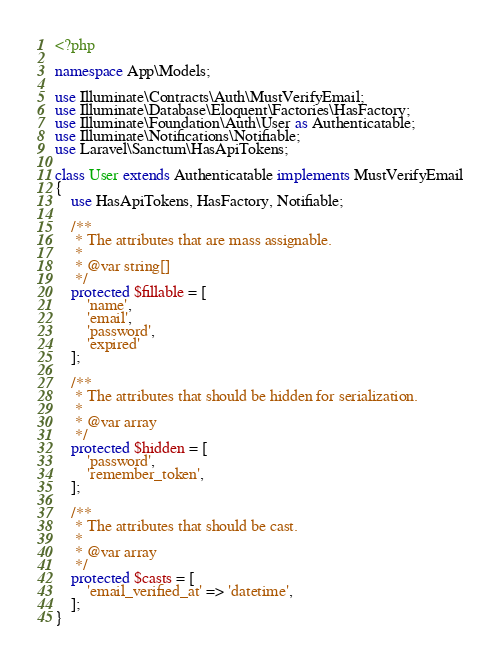<code> <loc_0><loc_0><loc_500><loc_500><_PHP_><?php

namespace App\Models;

use Illuminate\Contracts\Auth\MustVerifyEmail;
use Illuminate\Database\Eloquent\Factories\HasFactory;
use Illuminate\Foundation\Auth\User as Authenticatable;
use Illuminate\Notifications\Notifiable;
use Laravel\Sanctum\HasApiTokens;

class User extends Authenticatable implements MustVerifyEmail
{
    use HasApiTokens, HasFactory, Notifiable;

    /**
     * The attributes that are mass assignable.
     *
     * @var string[]
     */
    protected $fillable = [
        'name',
        'email',
        'password',
        'expired'
    ];

    /**
     * The attributes that should be hidden for serialization.
     *
     * @var array
     */
    protected $hidden = [
        'password',
        'remember_token',
    ];

    /**
     * The attributes that should be cast.
     *
     * @var array
     */
    protected $casts = [
        'email_verified_at' => 'datetime',
    ];
}
</code> 